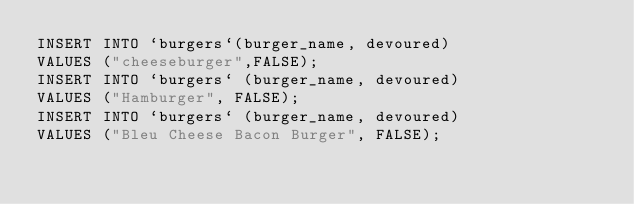<code> <loc_0><loc_0><loc_500><loc_500><_SQL_>INSERT INTO `burgers`(burger_name, devoured) 
VALUES ("cheeseburger",FALSE);
INSERT INTO `burgers` (burger_name, devoured)
VALUES ("Hamburger", FALSE);
INSERT INTO `burgers` (burger_name, devoured)
VALUES ("Bleu Cheese Bacon Burger", FALSE);</code> 